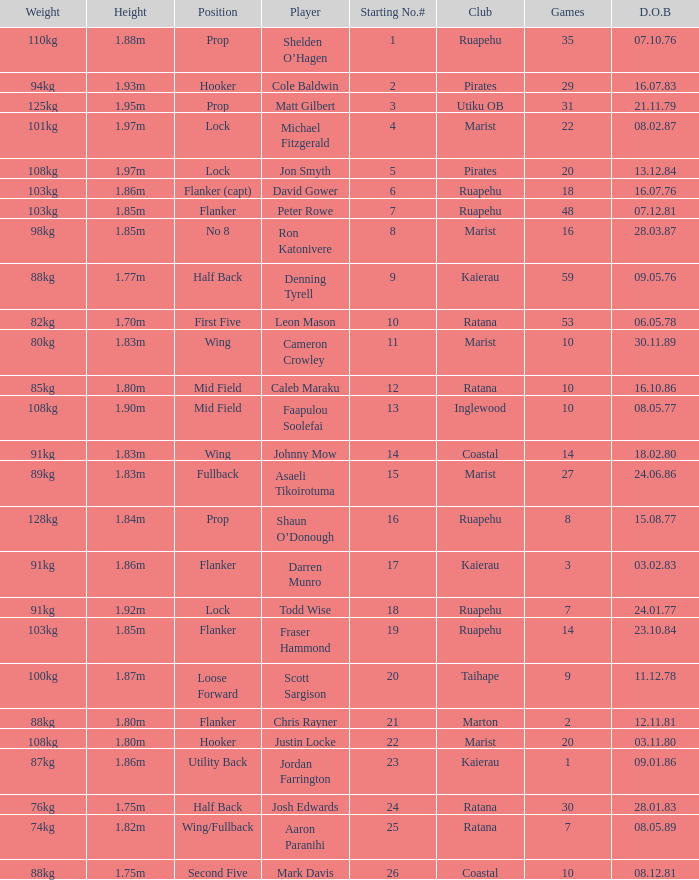What is the date of birth for the player in the Inglewood club? 80577.0. 